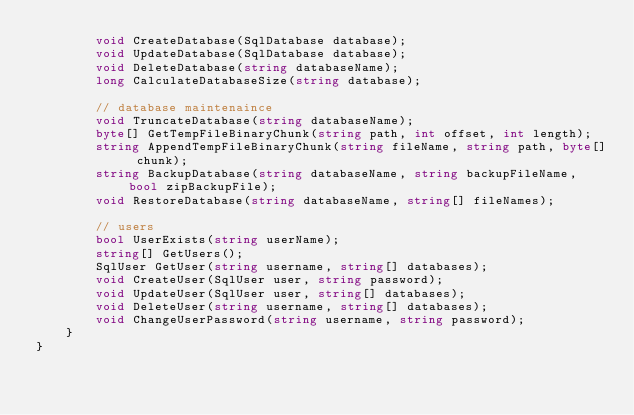Convert code to text. <code><loc_0><loc_0><loc_500><loc_500><_C#_>        void CreateDatabase(SqlDatabase database);
		void UpdateDatabase(SqlDatabase database);
		void DeleteDatabase(string databaseName);
		long CalculateDatabaseSize(string database);

		// database maintenaince
		void TruncateDatabase(string databaseName);
        byte[] GetTempFileBinaryChunk(string path, int offset, int length);
        string AppendTempFileBinaryChunk(string fileName, string path, byte[] chunk);
        string BackupDatabase(string databaseName, string backupFileName, bool zipBackupFile);
		void RestoreDatabase(string databaseName, string[] fileNames);

		// users
		bool UserExists(string userName);
        string[] GetUsers();
		SqlUser GetUser(string username, string[] databases);
		void CreateUser(SqlUser user, string password);
		void UpdateUser(SqlUser user, string[] databases);
        void DeleteUser(string username, string[] databases);
		void ChangeUserPassword(string username, string password);
    }
}
</code> 